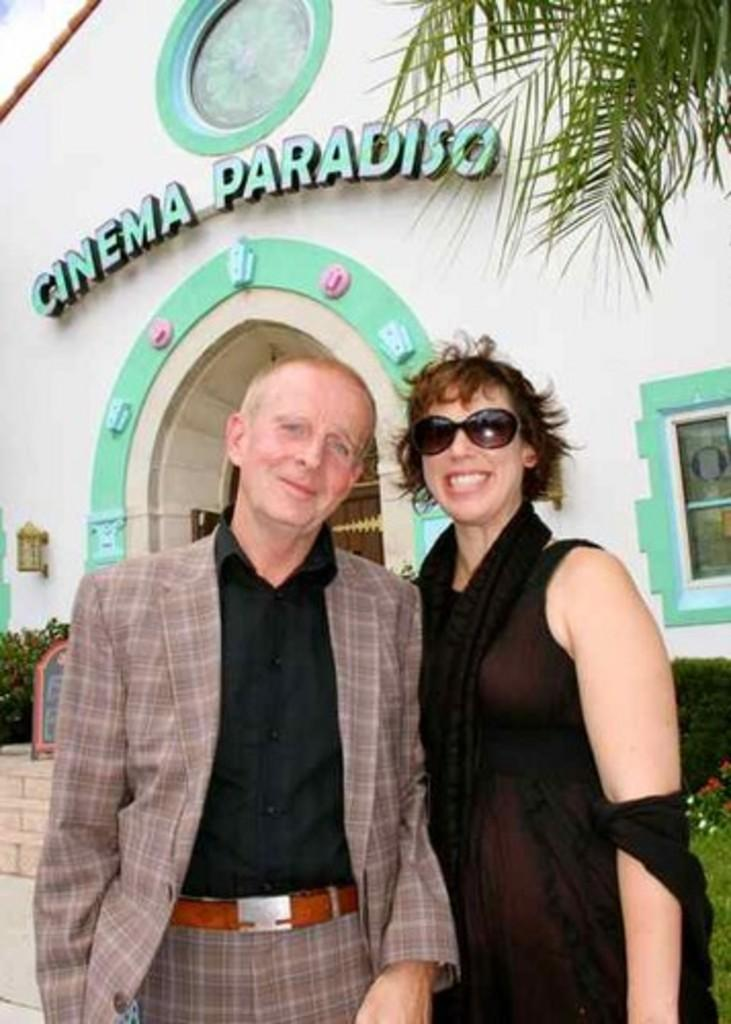How many people are in the image? There are two people in the image. What is the facial expression of the people in the image? The two people are smiling in the image. What is the woman wearing that is related to safety or protection? The woman is wearing goggles. What can be seen in the background of the image? In the background, there are plants, steps, a board, leaves, a building with a window, and some unspecified objects. What type of vessel is being used to paint the building in the background? There is no vessel or painting activity visible in the image. 